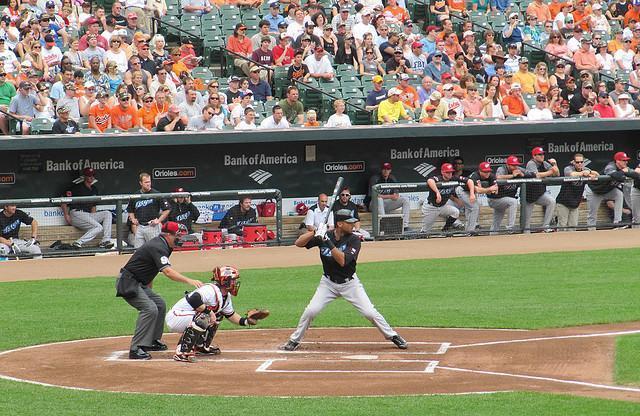What color is the umpire's helmet who is standing with his hand on the catcher's back?
Pick the correct solution from the four options below to address the question.
Options: Black, red, green, blue. Red. 